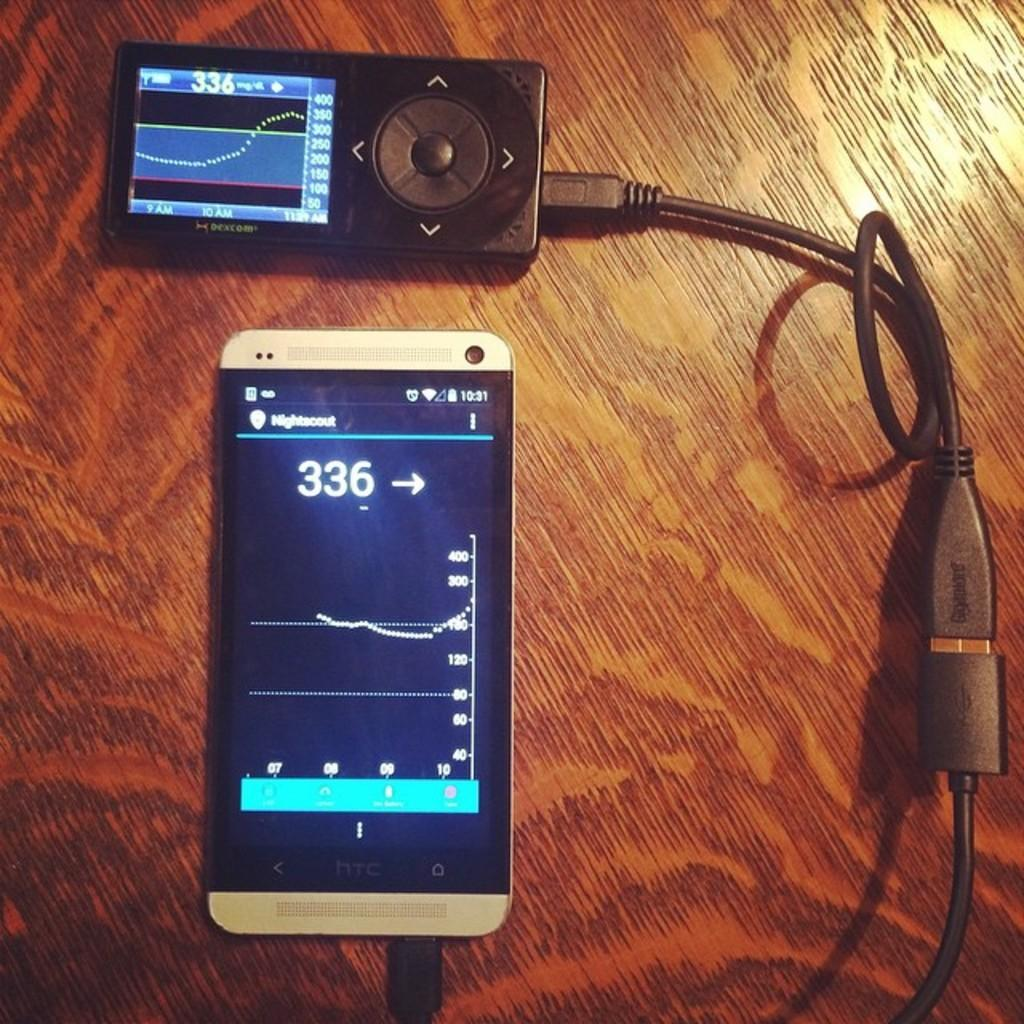What electronic device is visible in the image? There is a mobile phone in the image. What appears to be damaged or incomplete in the image? There is a truncated wire in the image. What object can be seen resting on a surface in the image? There is an object on a surface in the image. What type of wine is being poured from the self in the image? There is no self or wine present in the image. How does the wrist of the person holding the mobile phone look like in the image? There is no person or wrist visible in the image. 